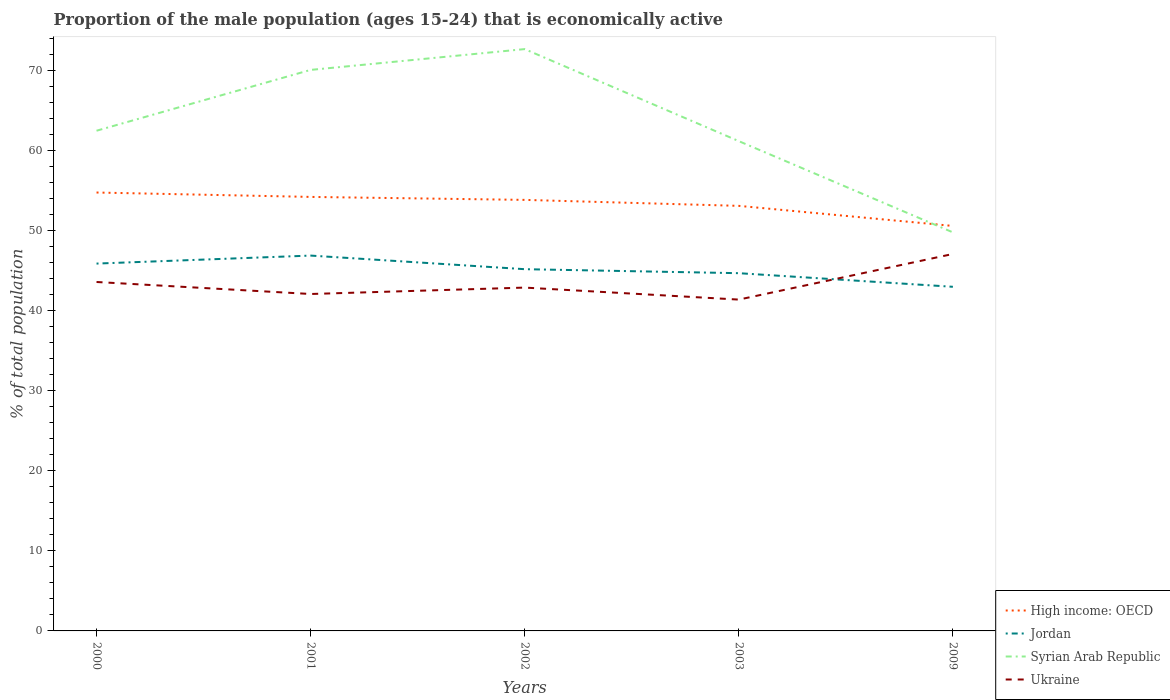How many different coloured lines are there?
Provide a short and direct response. 4. Does the line corresponding to Ukraine intersect with the line corresponding to High income: OECD?
Provide a succinct answer. No. Across all years, what is the maximum proportion of the male population that is economically active in High income: OECD?
Provide a succinct answer. 50.6. What is the total proportion of the male population that is economically active in Ukraine in the graph?
Your response must be concise. 0.7. What is the difference between the highest and the second highest proportion of the male population that is economically active in Syrian Arab Republic?
Ensure brevity in your answer.  22.9. What is the difference between the highest and the lowest proportion of the male population that is economically active in Ukraine?
Your answer should be very brief. 2. Is the proportion of the male population that is economically active in High income: OECD strictly greater than the proportion of the male population that is economically active in Ukraine over the years?
Give a very brief answer. No. How many lines are there?
Make the answer very short. 4. What is the difference between two consecutive major ticks on the Y-axis?
Keep it short and to the point. 10. Where does the legend appear in the graph?
Keep it short and to the point. Bottom right. What is the title of the graph?
Your answer should be very brief. Proportion of the male population (ages 15-24) that is economically active. What is the label or title of the X-axis?
Offer a very short reply. Years. What is the label or title of the Y-axis?
Offer a terse response. % of total population. What is the % of total population in High income: OECD in 2000?
Ensure brevity in your answer.  54.78. What is the % of total population in Jordan in 2000?
Ensure brevity in your answer.  45.9. What is the % of total population in Syrian Arab Republic in 2000?
Offer a terse response. 62.5. What is the % of total population in Ukraine in 2000?
Give a very brief answer. 43.6. What is the % of total population in High income: OECD in 2001?
Keep it short and to the point. 54.23. What is the % of total population of Jordan in 2001?
Keep it short and to the point. 46.9. What is the % of total population in Syrian Arab Republic in 2001?
Provide a short and direct response. 70.1. What is the % of total population of Ukraine in 2001?
Make the answer very short. 42.1. What is the % of total population of High income: OECD in 2002?
Your answer should be very brief. 53.86. What is the % of total population in Jordan in 2002?
Provide a short and direct response. 45.2. What is the % of total population in Syrian Arab Republic in 2002?
Your answer should be compact. 72.7. What is the % of total population in Ukraine in 2002?
Ensure brevity in your answer.  42.9. What is the % of total population of High income: OECD in 2003?
Provide a succinct answer. 53.11. What is the % of total population in Jordan in 2003?
Your answer should be compact. 44.7. What is the % of total population of Syrian Arab Republic in 2003?
Offer a very short reply. 61.2. What is the % of total population in Ukraine in 2003?
Your answer should be compact. 41.4. What is the % of total population in High income: OECD in 2009?
Ensure brevity in your answer.  50.6. What is the % of total population in Syrian Arab Republic in 2009?
Ensure brevity in your answer.  49.8. What is the % of total population in Ukraine in 2009?
Ensure brevity in your answer.  47.1. Across all years, what is the maximum % of total population in High income: OECD?
Provide a short and direct response. 54.78. Across all years, what is the maximum % of total population in Jordan?
Keep it short and to the point. 46.9. Across all years, what is the maximum % of total population in Syrian Arab Republic?
Offer a terse response. 72.7. Across all years, what is the maximum % of total population in Ukraine?
Your answer should be compact. 47.1. Across all years, what is the minimum % of total population of High income: OECD?
Provide a succinct answer. 50.6. Across all years, what is the minimum % of total population in Syrian Arab Republic?
Provide a succinct answer. 49.8. Across all years, what is the minimum % of total population in Ukraine?
Offer a terse response. 41.4. What is the total % of total population in High income: OECD in the graph?
Keep it short and to the point. 266.58. What is the total % of total population in Jordan in the graph?
Give a very brief answer. 225.7. What is the total % of total population in Syrian Arab Republic in the graph?
Give a very brief answer. 316.3. What is the total % of total population in Ukraine in the graph?
Ensure brevity in your answer.  217.1. What is the difference between the % of total population of High income: OECD in 2000 and that in 2001?
Keep it short and to the point. 0.55. What is the difference between the % of total population in Ukraine in 2000 and that in 2001?
Your response must be concise. 1.5. What is the difference between the % of total population of High income: OECD in 2000 and that in 2002?
Your response must be concise. 0.92. What is the difference between the % of total population in Syrian Arab Republic in 2000 and that in 2002?
Your response must be concise. -10.2. What is the difference between the % of total population of Ukraine in 2000 and that in 2002?
Your answer should be compact. 0.7. What is the difference between the % of total population of High income: OECD in 2000 and that in 2003?
Keep it short and to the point. 1.67. What is the difference between the % of total population in Jordan in 2000 and that in 2003?
Your answer should be compact. 1.2. What is the difference between the % of total population in Syrian Arab Republic in 2000 and that in 2003?
Give a very brief answer. 1.3. What is the difference between the % of total population in Ukraine in 2000 and that in 2003?
Provide a short and direct response. 2.2. What is the difference between the % of total population in High income: OECD in 2000 and that in 2009?
Make the answer very short. 4.17. What is the difference between the % of total population of Ukraine in 2000 and that in 2009?
Ensure brevity in your answer.  -3.5. What is the difference between the % of total population in High income: OECD in 2001 and that in 2002?
Your answer should be very brief. 0.37. What is the difference between the % of total population of Jordan in 2001 and that in 2002?
Ensure brevity in your answer.  1.7. What is the difference between the % of total population of Ukraine in 2001 and that in 2002?
Your answer should be compact. -0.8. What is the difference between the % of total population in High income: OECD in 2001 and that in 2003?
Offer a very short reply. 1.12. What is the difference between the % of total population in Jordan in 2001 and that in 2003?
Provide a succinct answer. 2.2. What is the difference between the % of total population of Syrian Arab Republic in 2001 and that in 2003?
Make the answer very short. 8.9. What is the difference between the % of total population in Ukraine in 2001 and that in 2003?
Give a very brief answer. 0.7. What is the difference between the % of total population of High income: OECD in 2001 and that in 2009?
Keep it short and to the point. 3.63. What is the difference between the % of total population of Syrian Arab Republic in 2001 and that in 2009?
Give a very brief answer. 20.3. What is the difference between the % of total population of Ukraine in 2001 and that in 2009?
Offer a very short reply. -5. What is the difference between the % of total population in High income: OECD in 2002 and that in 2003?
Your response must be concise. 0.75. What is the difference between the % of total population in Ukraine in 2002 and that in 2003?
Your response must be concise. 1.5. What is the difference between the % of total population in High income: OECD in 2002 and that in 2009?
Your response must be concise. 3.25. What is the difference between the % of total population of Jordan in 2002 and that in 2009?
Offer a very short reply. 2.2. What is the difference between the % of total population in Syrian Arab Republic in 2002 and that in 2009?
Ensure brevity in your answer.  22.9. What is the difference between the % of total population in High income: OECD in 2003 and that in 2009?
Keep it short and to the point. 2.51. What is the difference between the % of total population of Syrian Arab Republic in 2003 and that in 2009?
Make the answer very short. 11.4. What is the difference between the % of total population of Ukraine in 2003 and that in 2009?
Give a very brief answer. -5.7. What is the difference between the % of total population of High income: OECD in 2000 and the % of total population of Jordan in 2001?
Your answer should be very brief. 7.88. What is the difference between the % of total population in High income: OECD in 2000 and the % of total population in Syrian Arab Republic in 2001?
Make the answer very short. -15.32. What is the difference between the % of total population of High income: OECD in 2000 and the % of total population of Ukraine in 2001?
Ensure brevity in your answer.  12.68. What is the difference between the % of total population in Jordan in 2000 and the % of total population in Syrian Arab Republic in 2001?
Offer a very short reply. -24.2. What is the difference between the % of total population of Jordan in 2000 and the % of total population of Ukraine in 2001?
Give a very brief answer. 3.8. What is the difference between the % of total population of Syrian Arab Republic in 2000 and the % of total population of Ukraine in 2001?
Your response must be concise. 20.4. What is the difference between the % of total population in High income: OECD in 2000 and the % of total population in Jordan in 2002?
Provide a short and direct response. 9.58. What is the difference between the % of total population of High income: OECD in 2000 and the % of total population of Syrian Arab Republic in 2002?
Your response must be concise. -17.92. What is the difference between the % of total population of High income: OECD in 2000 and the % of total population of Ukraine in 2002?
Your answer should be compact. 11.88. What is the difference between the % of total population of Jordan in 2000 and the % of total population of Syrian Arab Republic in 2002?
Make the answer very short. -26.8. What is the difference between the % of total population in Syrian Arab Republic in 2000 and the % of total population in Ukraine in 2002?
Provide a succinct answer. 19.6. What is the difference between the % of total population in High income: OECD in 2000 and the % of total population in Jordan in 2003?
Provide a short and direct response. 10.08. What is the difference between the % of total population in High income: OECD in 2000 and the % of total population in Syrian Arab Republic in 2003?
Make the answer very short. -6.42. What is the difference between the % of total population in High income: OECD in 2000 and the % of total population in Ukraine in 2003?
Your answer should be very brief. 13.38. What is the difference between the % of total population in Jordan in 2000 and the % of total population in Syrian Arab Republic in 2003?
Keep it short and to the point. -15.3. What is the difference between the % of total population in Jordan in 2000 and the % of total population in Ukraine in 2003?
Provide a succinct answer. 4.5. What is the difference between the % of total population of Syrian Arab Republic in 2000 and the % of total population of Ukraine in 2003?
Keep it short and to the point. 21.1. What is the difference between the % of total population of High income: OECD in 2000 and the % of total population of Jordan in 2009?
Offer a very short reply. 11.78. What is the difference between the % of total population in High income: OECD in 2000 and the % of total population in Syrian Arab Republic in 2009?
Ensure brevity in your answer.  4.98. What is the difference between the % of total population in High income: OECD in 2000 and the % of total population in Ukraine in 2009?
Make the answer very short. 7.68. What is the difference between the % of total population of Jordan in 2000 and the % of total population of Syrian Arab Republic in 2009?
Give a very brief answer. -3.9. What is the difference between the % of total population of Jordan in 2000 and the % of total population of Ukraine in 2009?
Your answer should be very brief. -1.2. What is the difference between the % of total population in Syrian Arab Republic in 2000 and the % of total population in Ukraine in 2009?
Offer a terse response. 15.4. What is the difference between the % of total population in High income: OECD in 2001 and the % of total population in Jordan in 2002?
Offer a terse response. 9.03. What is the difference between the % of total population in High income: OECD in 2001 and the % of total population in Syrian Arab Republic in 2002?
Your answer should be very brief. -18.47. What is the difference between the % of total population of High income: OECD in 2001 and the % of total population of Ukraine in 2002?
Offer a terse response. 11.33. What is the difference between the % of total population of Jordan in 2001 and the % of total population of Syrian Arab Republic in 2002?
Offer a terse response. -25.8. What is the difference between the % of total population in Syrian Arab Republic in 2001 and the % of total population in Ukraine in 2002?
Your answer should be very brief. 27.2. What is the difference between the % of total population in High income: OECD in 2001 and the % of total population in Jordan in 2003?
Your response must be concise. 9.53. What is the difference between the % of total population of High income: OECD in 2001 and the % of total population of Syrian Arab Republic in 2003?
Your response must be concise. -6.97. What is the difference between the % of total population of High income: OECD in 2001 and the % of total population of Ukraine in 2003?
Offer a terse response. 12.83. What is the difference between the % of total population in Jordan in 2001 and the % of total population in Syrian Arab Republic in 2003?
Provide a short and direct response. -14.3. What is the difference between the % of total population in Syrian Arab Republic in 2001 and the % of total population in Ukraine in 2003?
Offer a terse response. 28.7. What is the difference between the % of total population in High income: OECD in 2001 and the % of total population in Jordan in 2009?
Ensure brevity in your answer.  11.23. What is the difference between the % of total population of High income: OECD in 2001 and the % of total population of Syrian Arab Republic in 2009?
Keep it short and to the point. 4.43. What is the difference between the % of total population of High income: OECD in 2001 and the % of total population of Ukraine in 2009?
Make the answer very short. 7.13. What is the difference between the % of total population of Jordan in 2001 and the % of total population of Ukraine in 2009?
Make the answer very short. -0.2. What is the difference between the % of total population of Syrian Arab Republic in 2001 and the % of total population of Ukraine in 2009?
Offer a very short reply. 23. What is the difference between the % of total population of High income: OECD in 2002 and the % of total population of Jordan in 2003?
Your response must be concise. 9.16. What is the difference between the % of total population in High income: OECD in 2002 and the % of total population in Syrian Arab Republic in 2003?
Offer a very short reply. -7.34. What is the difference between the % of total population in High income: OECD in 2002 and the % of total population in Ukraine in 2003?
Your answer should be compact. 12.46. What is the difference between the % of total population in Jordan in 2002 and the % of total population in Syrian Arab Republic in 2003?
Make the answer very short. -16. What is the difference between the % of total population of Syrian Arab Republic in 2002 and the % of total population of Ukraine in 2003?
Ensure brevity in your answer.  31.3. What is the difference between the % of total population in High income: OECD in 2002 and the % of total population in Jordan in 2009?
Offer a terse response. 10.86. What is the difference between the % of total population of High income: OECD in 2002 and the % of total population of Syrian Arab Republic in 2009?
Offer a very short reply. 4.06. What is the difference between the % of total population of High income: OECD in 2002 and the % of total population of Ukraine in 2009?
Your answer should be compact. 6.76. What is the difference between the % of total population of Syrian Arab Republic in 2002 and the % of total population of Ukraine in 2009?
Your answer should be very brief. 25.6. What is the difference between the % of total population of High income: OECD in 2003 and the % of total population of Jordan in 2009?
Offer a terse response. 10.11. What is the difference between the % of total population of High income: OECD in 2003 and the % of total population of Syrian Arab Republic in 2009?
Your response must be concise. 3.31. What is the difference between the % of total population of High income: OECD in 2003 and the % of total population of Ukraine in 2009?
Make the answer very short. 6.01. What is the difference between the % of total population of Jordan in 2003 and the % of total population of Syrian Arab Republic in 2009?
Offer a terse response. -5.1. What is the difference between the % of total population of Jordan in 2003 and the % of total population of Ukraine in 2009?
Give a very brief answer. -2.4. What is the average % of total population in High income: OECD per year?
Give a very brief answer. 53.32. What is the average % of total population of Jordan per year?
Your answer should be very brief. 45.14. What is the average % of total population in Syrian Arab Republic per year?
Provide a short and direct response. 63.26. What is the average % of total population of Ukraine per year?
Your answer should be compact. 43.42. In the year 2000, what is the difference between the % of total population in High income: OECD and % of total population in Jordan?
Offer a very short reply. 8.88. In the year 2000, what is the difference between the % of total population of High income: OECD and % of total population of Syrian Arab Republic?
Give a very brief answer. -7.72. In the year 2000, what is the difference between the % of total population of High income: OECD and % of total population of Ukraine?
Provide a short and direct response. 11.18. In the year 2000, what is the difference between the % of total population in Jordan and % of total population in Syrian Arab Republic?
Give a very brief answer. -16.6. In the year 2001, what is the difference between the % of total population of High income: OECD and % of total population of Jordan?
Give a very brief answer. 7.33. In the year 2001, what is the difference between the % of total population of High income: OECD and % of total population of Syrian Arab Republic?
Provide a succinct answer. -15.87. In the year 2001, what is the difference between the % of total population in High income: OECD and % of total population in Ukraine?
Provide a short and direct response. 12.13. In the year 2001, what is the difference between the % of total population in Jordan and % of total population in Syrian Arab Republic?
Provide a succinct answer. -23.2. In the year 2001, what is the difference between the % of total population of Syrian Arab Republic and % of total population of Ukraine?
Keep it short and to the point. 28. In the year 2002, what is the difference between the % of total population in High income: OECD and % of total population in Jordan?
Keep it short and to the point. 8.66. In the year 2002, what is the difference between the % of total population of High income: OECD and % of total population of Syrian Arab Republic?
Keep it short and to the point. -18.84. In the year 2002, what is the difference between the % of total population in High income: OECD and % of total population in Ukraine?
Give a very brief answer. 10.96. In the year 2002, what is the difference between the % of total population in Jordan and % of total population in Syrian Arab Republic?
Keep it short and to the point. -27.5. In the year 2002, what is the difference between the % of total population of Syrian Arab Republic and % of total population of Ukraine?
Offer a terse response. 29.8. In the year 2003, what is the difference between the % of total population of High income: OECD and % of total population of Jordan?
Offer a terse response. 8.41. In the year 2003, what is the difference between the % of total population in High income: OECD and % of total population in Syrian Arab Republic?
Offer a very short reply. -8.09. In the year 2003, what is the difference between the % of total population of High income: OECD and % of total population of Ukraine?
Your response must be concise. 11.71. In the year 2003, what is the difference between the % of total population of Jordan and % of total population of Syrian Arab Republic?
Provide a short and direct response. -16.5. In the year 2003, what is the difference between the % of total population of Syrian Arab Republic and % of total population of Ukraine?
Your answer should be very brief. 19.8. In the year 2009, what is the difference between the % of total population of High income: OECD and % of total population of Jordan?
Ensure brevity in your answer.  7.6. In the year 2009, what is the difference between the % of total population in High income: OECD and % of total population in Syrian Arab Republic?
Provide a short and direct response. 0.8. In the year 2009, what is the difference between the % of total population in High income: OECD and % of total population in Ukraine?
Offer a terse response. 3.5. In the year 2009, what is the difference between the % of total population in Jordan and % of total population in Ukraine?
Ensure brevity in your answer.  -4.1. In the year 2009, what is the difference between the % of total population of Syrian Arab Republic and % of total population of Ukraine?
Give a very brief answer. 2.7. What is the ratio of the % of total population in Jordan in 2000 to that in 2001?
Provide a short and direct response. 0.98. What is the ratio of the % of total population of Syrian Arab Republic in 2000 to that in 2001?
Your response must be concise. 0.89. What is the ratio of the % of total population of Ukraine in 2000 to that in 2001?
Provide a succinct answer. 1.04. What is the ratio of the % of total population in High income: OECD in 2000 to that in 2002?
Give a very brief answer. 1.02. What is the ratio of the % of total population of Jordan in 2000 to that in 2002?
Your response must be concise. 1.02. What is the ratio of the % of total population of Syrian Arab Republic in 2000 to that in 2002?
Your answer should be very brief. 0.86. What is the ratio of the % of total population of Ukraine in 2000 to that in 2002?
Your answer should be very brief. 1.02. What is the ratio of the % of total population of High income: OECD in 2000 to that in 2003?
Offer a terse response. 1.03. What is the ratio of the % of total population in Jordan in 2000 to that in 2003?
Give a very brief answer. 1.03. What is the ratio of the % of total population in Syrian Arab Republic in 2000 to that in 2003?
Give a very brief answer. 1.02. What is the ratio of the % of total population of Ukraine in 2000 to that in 2003?
Provide a short and direct response. 1.05. What is the ratio of the % of total population in High income: OECD in 2000 to that in 2009?
Offer a very short reply. 1.08. What is the ratio of the % of total population of Jordan in 2000 to that in 2009?
Make the answer very short. 1.07. What is the ratio of the % of total population in Syrian Arab Republic in 2000 to that in 2009?
Give a very brief answer. 1.25. What is the ratio of the % of total population in Ukraine in 2000 to that in 2009?
Offer a terse response. 0.93. What is the ratio of the % of total population of Jordan in 2001 to that in 2002?
Offer a terse response. 1.04. What is the ratio of the % of total population in Syrian Arab Republic in 2001 to that in 2002?
Make the answer very short. 0.96. What is the ratio of the % of total population in Ukraine in 2001 to that in 2002?
Ensure brevity in your answer.  0.98. What is the ratio of the % of total population of High income: OECD in 2001 to that in 2003?
Offer a very short reply. 1.02. What is the ratio of the % of total population in Jordan in 2001 to that in 2003?
Your answer should be very brief. 1.05. What is the ratio of the % of total population in Syrian Arab Republic in 2001 to that in 2003?
Give a very brief answer. 1.15. What is the ratio of the % of total population in Ukraine in 2001 to that in 2003?
Offer a very short reply. 1.02. What is the ratio of the % of total population in High income: OECD in 2001 to that in 2009?
Your answer should be compact. 1.07. What is the ratio of the % of total population in Jordan in 2001 to that in 2009?
Provide a short and direct response. 1.09. What is the ratio of the % of total population in Syrian Arab Republic in 2001 to that in 2009?
Offer a terse response. 1.41. What is the ratio of the % of total population of Ukraine in 2001 to that in 2009?
Offer a very short reply. 0.89. What is the ratio of the % of total population in High income: OECD in 2002 to that in 2003?
Give a very brief answer. 1.01. What is the ratio of the % of total population in Jordan in 2002 to that in 2003?
Your answer should be very brief. 1.01. What is the ratio of the % of total population of Syrian Arab Republic in 2002 to that in 2003?
Give a very brief answer. 1.19. What is the ratio of the % of total population in Ukraine in 2002 to that in 2003?
Provide a short and direct response. 1.04. What is the ratio of the % of total population in High income: OECD in 2002 to that in 2009?
Your answer should be very brief. 1.06. What is the ratio of the % of total population in Jordan in 2002 to that in 2009?
Keep it short and to the point. 1.05. What is the ratio of the % of total population in Syrian Arab Republic in 2002 to that in 2009?
Your answer should be compact. 1.46. What is the ratio of the % of total population of Ukraine in 2002 to that in 2009?
Provide a short and direct response. 0.91. What is the ratio of the % of total population in High income: OECD in 2003 to that in 2009?
Offer a very short reply. 1.05. What is the ratio of the % of total population in Jordan in 2003 to that in 2009?
Make the answer very short. 1.04. What is the ratio of the % of total population in Syrian Arab Republic in 2003 to that in 2009?
Ensure brevity in your answer.  1.23. What is the ratio of the % of total population of Ukraine in 2003 to that in 2009?
Keep it short and to the point. 0.88. What is the difference between the highest and the second highest % of total population in High income: OECD?
Give a very brief answer. 0.55. What is the difference between the highest and the second highest % of total population in Syrian Arab Republic?
Your answer should be compact. 2.6. What is the difference between the highest and the second highest % of total population in Ukraine?
Ensure brevity in your answer.  3.5. What is the difference between the highest and the lowest % of total population in High income: OECD?
Offer a very short reply. 4.17. What is the difference between the highest and the lowest % of total population of Syrian Arab Republic?
Your answer should be compact. 22.9. 